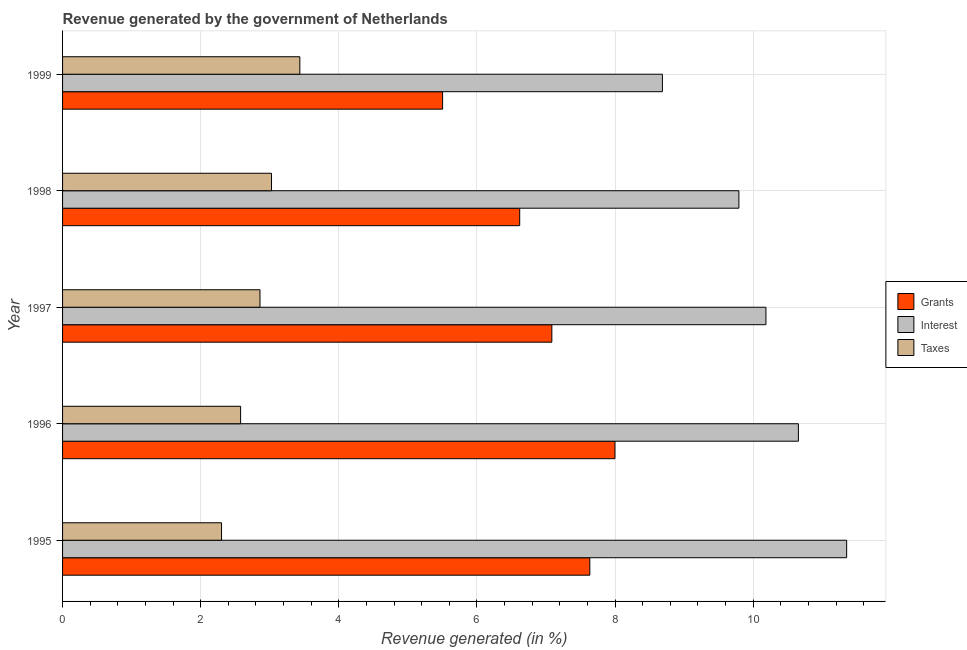How many groups of bars are there?
Provide a short and direct response. 5. Are the number of bars per tick equal to the number of legend labels?
Your response must be concise. Yes. In how many cases, is the number of bars for a given year not equal to the number of legend labels?
Your response must be concise. 0. What is the percentage of revenue generated by grants in 1998?
Make the answer very short. 6.62. Across all years, what is the maximum percentage of revenue generated by interest?
Give a very brief answer. 11.35. Across all years, what is the minimum percentage of revenue generated by grants?
Provide a succinct answer. 5.5. In which year was the percentage of revenue generated by interest maximum?
Offer a terse response. 1995. What is the total percentage of revenue generated by taxes in the graph?
Give a very brief answer. 14.2. What is the difference between the percentage of revenue generated by grants in 1996 and that in 1998?
Ensure brevity in your answer.  1.38. What is the difference between the percentage of revenue generated by interest in 1997 and the percentage of revenue generated by grants in 1995?
Your response must be concise. 2.55. What is the average percentage of revenue generated by interest per year?
Your response must be concise. 10.13. In the year 1999, what is the difference between the percentage of revenue generated by interest and percentage of revenue generated by taxes?
Offer a terse response. 5.25. In how many years, is the percentage of revenue generated by interest greater than 7.6 %?
Keep it short and to the point. 5. What is the ratio of the percentage of revenue generated by interest in 1997 to that in 1998?
Make the answer very short. 1.04. What is the difference between the highest and the second highest percentage of revenue generated by taxes?
Your answer should be compact. 0.41. What is the difference between the highest and the lowest percentage of revenue generated by interest?
Your answer should be compact. 2.67. In how many years, is the percentage of revenue generated by taxes greater than the average percentage of revenue generated by taxes taken over all years?
Ensure brevity in your answer.  3. Is the sum of the percentage of revenue generated by interest in 1995 and 1996 greater than the maximum percentage of revenue generated by taxes across all years?
Give a very brief answer. Yes. What does the 1st bar from the top in 1997 represents?
Provide a short and direct response. Taxes. What does the 1st bar from the bottom in 1998 represents?
Provide a succinct answer. Grants. Is it the case that in every year, the sum of the percentage of revenue generated by grants and percentage of revenue generated by interest is greater than the percentage of revenue generated by taxes?
Ensure brevity in your answer.  Yes. How many bars are there?
Offer a terse response. 15. Are all the bars in the graph horizontal?
Provide a short and direct response. Yes. What is the difference between two consecutive major ticks on the X-axis?
Make the answer very short. 2. Are the values on the major ticks of X-axis written in scientific E-notation?
Keep it short and to the point. No. What is the title of the graph?
Offer a very short reply. Revenue generated by the government of Netherlands. What is the label or title of the X-axis?
Keep it short and to the point. Revenue generated (in %). What is the label or title of the Y-axis?
Offer a terse response. Year. What is the Revenue generated (in %) of Grants in 1995?
Provide a succinct answer. 7.63. What is the Revenue generated (in %) of Interest in 1995?
Make the answer very short. 11.35. What is the Revenue generated (in %) of Taxes in 1995?
Offer a very short reply. 2.3. What is the Revenue generated (in %) in Grants in 1996?
Your response must be concise. 8. What is the Revenue generated (in %) in Interest in 1996?
Your answer should be very brief. 10.66. What is the Revenue generated (in %) in Taxes in 1996?
Ensure brevity in your answer.  2.58. What is the Revenue generated (in %) of Grants in 1997?
Ensure brevity in your answer.  7.09. What is the Revenue generated (in %) of Interest in 1997?
Your answer should be very brief. 10.19. What is the Revenue generated (in %) of Taxes in 1997?
Your answer should be very brief. 2.86. What is the Revenue generated (in %) in Grants in 1998?
Provide a succinct answer. 6.62. What is the Revenue generated (in %) in Interest in 1998?
Your answer should be compact. 9.79. What is the Revenue generated (in %) of Taxes in 1998?
Your answer should be compact. 3.03. What is the Revenue generated (in %) of Grants in 1999?
Ensure brevity in your answer.  5.5. What is the Revenue generated (in %) in Interest in 1999?
Offer a very short reply. 8.69. What is the Revenue generated (in %) in Taxes in 1999?
Your answer should be compact. 3.44. Across all years, what is the maximum Revenue generated (in %) of Grants?
Your answer should be very brief. 8. Across all years, what is the maximum Revenue generated (in %) in Interest?
Offer a very short reply. 11.35. Across all years, what is the maximum Revenue generated (in %) of Taxes?
Provide a short and direct response. 3.44. Across all years, what is the minimum Revenue generated (in %) of Grants?
Your response must be concise. 5.5. Across all years, what is the minimum Revenue generated (in %) in Interest?
Provide a succinct answer. 8.69. Across all years, what is the minimum Revenue generated (in %) in Taxes?
Your answer should be very brief. 2.3. What is the total Revenue generated (in %) in Grants in the graph?
Make the answer very short. 34.84. What is the total Revenue generated (in %) of Interest in the graph?
Provide a succinct answer. 50.67. What is the total Revenue generated (in %) of Taxes in the graph?
Offer a terse response. 14.2. What is the difference between the Revenue generated (in %) in Grants in 1995 and that in 1996?
Give a very brief answer. -0.36. What is the difference between the Revenue generated (in %) of Interest in 1995 and that in 1996?
Provide a succinct answer. 0.7. What is the difference between the Revenue generated (in %) of Taxes in 1995 and that in 1996?
Provide a succinct answer. -0.28. What is the difference between the Revenue generated (in %) of Grants in 1995 and that in 1997?
Offer a terse response. 0.55. What is the difference between the Revenue generated (in %) of Interest in 1995 and that in 1997?
Make the answer very short. 1.17. What is the difference between the Revenue generated (in %) in Taxes in 1995 and that in 1997?
Offer a terse response. -0.56. What is the difference between the Revenue generated (in %) in Grants in 1995 and that in 1998?
Provide a succinct answer. 1.02. What is the difference between the Revenue generated (in %) in Interest in 1995 and that in 1998?
Make the answer very short. 1.56. What is the difference between the Revenue generated (in %) in Taxes in 1995 and that in 1998?
Your answer should be compact. -0.72. What is the difference between the Revenue generated (in %) in Grants in 1995 and that in 1999?
Provide a short and direct response. 2.13. What is the difference between the Revenue generated (in %) of Interest in 1995 and that in 1999?
Offer a very short reply. 2.67. What is the difference between the Revenue generated (in %) in Taxes in 1995 and that in 1999?
Offer a very short reply. -1.13. What is the difference between the Revenue generated (in %) in Grants in 1996 and that in 1997?
Offer a terse response. 0.91. What is the difference between the Revenue generated (in %) in Interest in 1996 and that in 1997?
Offer a very short reply. 0.47. What is the difference between the Revenue generated (in %) in Taxes in 1996 and that in 1997?
Provide a succinct answer. -0.28. What is the difference between the Revenue generated (in %) of Grants in 1996 and that in 1998?
Give a very brief answer. 1.38. What is the difference between the Revenue generated (in %) of Interest in 1996 and that in 1998?
Your response must be concise. 0.86. What is the difference between the Revenue generated (in %) of Taxes in 1996 and that in 1998?
Give a very brief answer. -0.45. What is the difference between the Revenue generated (in %) in Grants in 1996 and that in 1999?
Your answer should be compact. 2.5. What is the difference between the Revenue generated (in %) of Interest in 1996 and that in 1999?
Keep it short and to the point. 1.97. What is the difference between the Revenue generated (in %) of Taxes in 1996 and that in 1999?
Provide a succinct answer. -0.86. What is the difference between the Revenue generated (in %) in Grants in 1997 and that in 1998?
Provide a succinct answer. 0.47. What is the difference between the Revenue generated (in %) in Interest in 1997 and that in 1998?
Keep it short and to the point. 0.39. What is the difference between the Revenue generated (in %) in Taxes in 1997 and that in 1998?
Provide a short and direct response. -0.17. What is the difference between the Revenue generated (in %) in Grants in 1997 and that in 1999?
Your answer should be very brief. 1.58. What is the difference between the Revenue generated (in %) of Interest in 1997 and that in 1999?
Your answer should be very brief. 1.5. What is the difference between the Revenue generated (in %) in Taxes in 1997 and that in 1999?
Your answer should be compact. -0.58. What is the difference between the Revenue generated (in %) of Grants in 1998 and that in 1999?
Your answer should be compact. 1.12. What is the difference between the Revenue generated (in %) in Interest in 1998 and that in 1999?
Provide a succinct answer. 1.11. What is the difference between the Revenue generated (in %) of Taxes in 1998 and that in 1999?
Make the answer very short. -0.41. What is the difference between the Revenue generated (in %) in Grants in 1995 and the Revenue generated (in %) in Interest in 1996?
Make the answer very short. -3.02. What is the difference between the Revenue generated (in %) of Grants in 1995 and the Revenue generated (in %) of Taxes in 1996?
Your answer should be compact. 5.06. What is the difference between the Revenue generated (in %) in Interest in 1995 and the Revenue generated (in %) in Taxes in 1996?
Give a very brief answer. 8.78. What is the difference between the Revenue generated (in %) in Grants in 1995 and the Revenue generated (in %) in Interest in 1997?
Provide a succinct answer. -2.55. What is the difference between the Revenue generated (in %) in Grants in 1995 and the Revenue generated (in %) in Taxes in 1997?
Keep it short and to the point. 4.78. What is the difference between the Revenue generated (in %) in Interest in 1995 and the Revenue generated (in %) in Taxes in 1997?
Offer a terse response. 8.5. What is the difference between the Revenue generated (in %) in Grants in 1995 and the Revenue generated (in %) in Interest in 1998?
Your response must be concise. -2.16. What is the difference between the Revenue generated (in %) of Grants in 1995 and the Revenue generated (in %) of Taxes in 1998?
Your answer should be very brief. 4.61. What is the difference between the Revenue generated (in %) of Interest in 1995 and the Revenue generated (in %) of Taxes in 1998?
Keep it short and to the point. 8.33. What is the difference between the Revenue generated (in %) in Grants in 1995 and the Revenue generated (in %) in Interest in 1999?
Provide a succinct answer. -1.05. What is the difference between the Revenue generated (in %) of Grants in 1995 and the Revenue generated (in %) of Taxes in 1999?
Offer a terse response. 4.2. What is the difference between the Revenue generated (in %) in Interest in 1995 and the Revenue generated (in %) in Taxes in 1999?
Your answer should be very brief. 7.92. What is the difference between the Revenue generated (in %) of Grants in 1996 and the Revenue generated (in %) of Interest in 1997?
Ensure brevity in your answer.  -2.19. What is the difference between the Revenue generated (in %) in Grants in 1996 and the Revenue generated (in %) in Taxes in 1997?
Offer a very short reply. 5.14. What is the difference between the Revenue generated (in %) of Interest in 1996 and the Revenue generated (in %) of Taxes in 1997?
Ensure brevity in your answer.  7.8. What is the difference between the Revenue generated (in %) in Grants in 1996 and the Revenue generated (in %) in Interest in 1998?
Your answer should be very brief. -1.79. What is the difference between the Revenue generated (in %) of Grants in 1996 and the Revenue generated (in %) of Taxes in 1998?
Keep it short and to the point. 4.97. What is the difference between the Revenue generated (in %) of Interest in 1996 and the Revenue generated (in %) of Taxes in 1998?
Keep it short and to the point. 7.63. What is the difference between the Revenue generated (in %) in Grants in 1996 and the Revenue generated (in %) in Interest in 1999?
Provide a succinct answer. -0.69. What is the difference between the Revenue generated (in %) in Grants in 1996 and the Revenue generated (in %) in Taxes in 1999?
Keep it short and to the point. 4.56. What is the difference between the Revenue generated (in %) of Interest in 1996 and the Revenue generated (in %) of Taxes in 1999?
Provide a short and direct response. 7.22. What is the difference between the Revenue generated (in %) of Grants in 1997 and the Revenue generated (in %) of Interest in 1998?
Make the answer very short. -2.71. What is the difference between the Revenue generated (in %) in Grants in 1997 and the Revenue generated (in %) in Taxes in 1998?
Give a very brief answer. 4.06. What is the difference between the Revenue generated (in %) in Interest in 1997 and the Revenue generated (in %) in Taxes in 1998?
Your answer should be very brief. 7.16. What is the difference between the Revenue generated (in %) in Grants in 1997 and the Revenue generated (in %) in Interest in 1999?
Keep it short and to the point. -1.6. What is the difference between the Revenue generated (in %) of Grants in 1997 and the Revenue generated (in %) of Taxes in 1999?
Your answer should be very brief. 3.65. What is the difference between the Revenue generated (in %) of Interest in 1997 and the Revenue generated (in %) of Taxes in 1999?
Offer a very short reply. 6.75. What is the difference between the Revenue generated (in %) in Grants in 1998 and the Revenue generated (in %) in Interest in 1999?
Ensure brevity in your answer.  -2.07. What is the difference between the Revenue generated (in %) of Grants in 1998 and the Revenue generated (in %) of Taxes in 1999?
Your answer should be compact. 3.18. What is the difference between the Revenue generated (in %) of Interest in 1998 and the Revenue generated (in %) of Taxes in 1999?
Keep it short and to the point. 6.36. What is the average Revenue generated (in %) of Grants per year?
Offer a very short reply. 6.97. What is the average Revenue generated (in %) in Interest per year?
Offer a terse response. 10.13. What is the average Revenue generated (in %) in Taxes per year?
Provide a short and direct response. 2.84. In the year 1995, what is the difference between the Revenue generated (in %) of Grants and Revenue generated (in %) of Interest?
Make the answer very short. -3.72. In the year 1995, what is the difference between the Revenue generated (in %) in Grants and Revenue generated (in %) in Taxes?
Your answer should be very brief. 5.33. In the year 1995, what is the difference between the Revenue generated (in %) in Interest and Revenue generated (in %) in Taxes?
Ensure brevity in your answer.  9.05. In the year 1996, what is the difference between the Revenue generated (in %) in Grants and Revenue generated (in %) in Interest?
Keep it short and to the point. -2.66. In the year 1996, what is the difference between the Revenue generated (in %) of Grants and Revenue generated (in %) of Taxes?
Give a very brief answer. 5.42. In the year 1996, what is the difference between the Revenue generated (in %) of Interest and Revenue generated (in %) of Taxes?
Give a very brief answer. 8.08. In the year 1997, what is the difference between the Revenue generated (in %) in Grants and Revenue generated (in %) in Interest?
Make the answer very short. -3.1. In the year 1997, what is the difference between the Revenue generated (in %) of Grants and Revenue generated (in %) of Taxes?
Your answer should be compact. 4.23. In the year 1997, what is the difference between the Revenue generated (in %) of Interest and Revenue generated (in %) of Taxes?
Provide a short and direct response. 7.33. In the year 1998, what is the difference between the Revenue generated (in %) of Grants and Revenue generated (in %) of Interest?
Offer a very short reply. -3.17. In the year 1998, what is the difference between the Revenue generated (in %) in Grants and Revenue generated (in %) in Taxes?
Provide a short and direct response. 3.59. In the year 1998, what is the difference between the Revenue generated (in %) of Interest and Revenue generated (in %) of Taxes?
Your answer should be very brief. 6.77. In the year 1999, what is the difference between the Revenue generated (in %) of Grants and Revenue generated (in %) of Interest?
Provide a short and direct response. -3.18. In the year 1999, what is the difference between the Revenue generated (in %) of Grants and Revenue generated (in %) of Taxes?
Your response must be concise. 2.07. In the year 1999, what is the difference between the Revenue generated (in %) in Interest and Revenue generated (in %) in Taxes?
Offer a very short reply. 5.25. What is the ratio of the Revenue generated (in %) in Grants in 1995 to that in 1996?
Ensure brevity in your answer.  0.95. What is the ratio of the Revenue generated (in %) in Interest in 1995 to that in 1996?
Give a very brief answer. 1.07. What is the ratio of the Revenue generated (in %) of Taxes in 1995 to that in 1996?
Your answer should be compact. 0.89. What is the ratio of the Revenue generated (in %) of Grants in 1995 to that in 1997?
Provide a short and direct response. 1.08. What is the ratio of the Revenue generated (in %) of Interest in 1995 to that in 1997?
Your answer should be very brief. 1.11. What is the ratio of the Revenue generated (in %) of Taxes in 1995 to that in 1997?
Offer a very short reply. 0.81. What is the ratio of the Revenue generated (in %) in Grants in 1995 to that in 1998?
Keep it short and to the point. 1.15. What is the ratio of the Revenue generated (in %) of Interest in 1995 to that in 1998?
Keep it short and to the point. 1.16. What is the ratio of the Revenue generated (in %) of Taxes in 1995 to that in 1998?
Keep it short and to the point. 0.76. What is the ratio of the Revenue generated (in %) of Grants in 1995 to that in 1999?
Make the answer very short. 1.39. What is the ratio of the Revenue generated (in %) of Interest in 1995 to that in 1999?
Provide a succinct answer. 1.31. What is the ratio of the Revenue generated (in %) of Taxes in 1995 to that in 1999?
Your response must be concise. 0.67. What is the ratio of the Revenue generated (in %) in Grants in 1996 to that in 1997?
Your response must be concise. 1.13. What is the ratio of the Revenue generated (in %) of Interest in 1996 to that in 1997?
Provide a succinct answer. 1.05. What is the ratio of the Revenue generated (in %) of Taxes in 1996 to that in 1997?
Keep it short and to the point. 0.9. What is the ratio of the Revenue generated (in %) in Grants in 1996 to that in 1998?
Make the answer very short. 1.21. What is the ratio of the Revenue generated (in %) in Interest in 1996 to that in 1998?
Offer a very short reply. 1.09. What is the ratio of the Revenue generated (in %) in Taxes in 1996 to that in 1998?
Keep it short and to the point. 0.85. What is the ratio of the Revenue generated (in %) of Grants in 1996 to that in 1999?
Give a very brief answer. 1.45. What is the ratio of the Revenue generated (in %) in Interest in 1996 to that in 1999?
Provide a short and direct response. 1.23. What is the ratio of the Revenue generated (in %) of Taxes in 1996 to that in 1999?
Offer a very short reply. 0.75. What is the ratio of the Revenue generated (in %) in Grants in 1997 to that in 1998?
Provide a succinct answer. 1.07. What is the ratio of the Revenue generated (in %) in Interest in 1997 to that in 1998?
Make the answer very short. 1.04. What is the ratio of the Revenue generated (in %) of Taxes in 1997 to that in 1998?
Provide a succinct answer. 0.94. What is the ratio of the Revenue generated (in %) of Grants in 1997 to that in 1999?
Provide a short and direct response. 1.29. What is the ratio of the Revenue generated (in %) of Interest in 1997 to that in 1999?
Give a very brief answer. 1.17. What is the ratio of the Revenue generated (in %) of Taxes in 1997 to that in 1999?
Provide a succinct answer. 0.83. What is the ratio of the Revenue generated (in %) of Grants in 1998 to that in 1999?
Keep it short and to the point. 1.2. What is the ratio of the Revenue generated (in %) in Interest in 1998 to that in 1999?
Provide a succinct answer. 1.13. What is the ratio of the Revenue generated (in %) in Taxes in 1998 to that in 1999?
Offer a very short reply. 0.88. What is the difference between the highest and the second highest Revenue generated (in %) in Grants?
Your answer should be very brief. 0.36. What is the difference between the highest and the second highest Revenue generated (in %) in Interest?
Provide a short and direct response. 0.7. What is the difference between the highest and the second highest Revenue generated (in %) in Taxes?
Keep it short and to the point. 0.41. What is the difference between the highest and the lowest Revenue generated (in %) in Grants?
Give a very brief answer. 2.5. What is the difference between the highest and the lowest Revenue generated (in %) of Interest?
Keep it short and to the point. 2.67. What is the difference between the highest and the lowest Revenue generated (in %) in Taxes?
Offer a terse response. 1.13. 